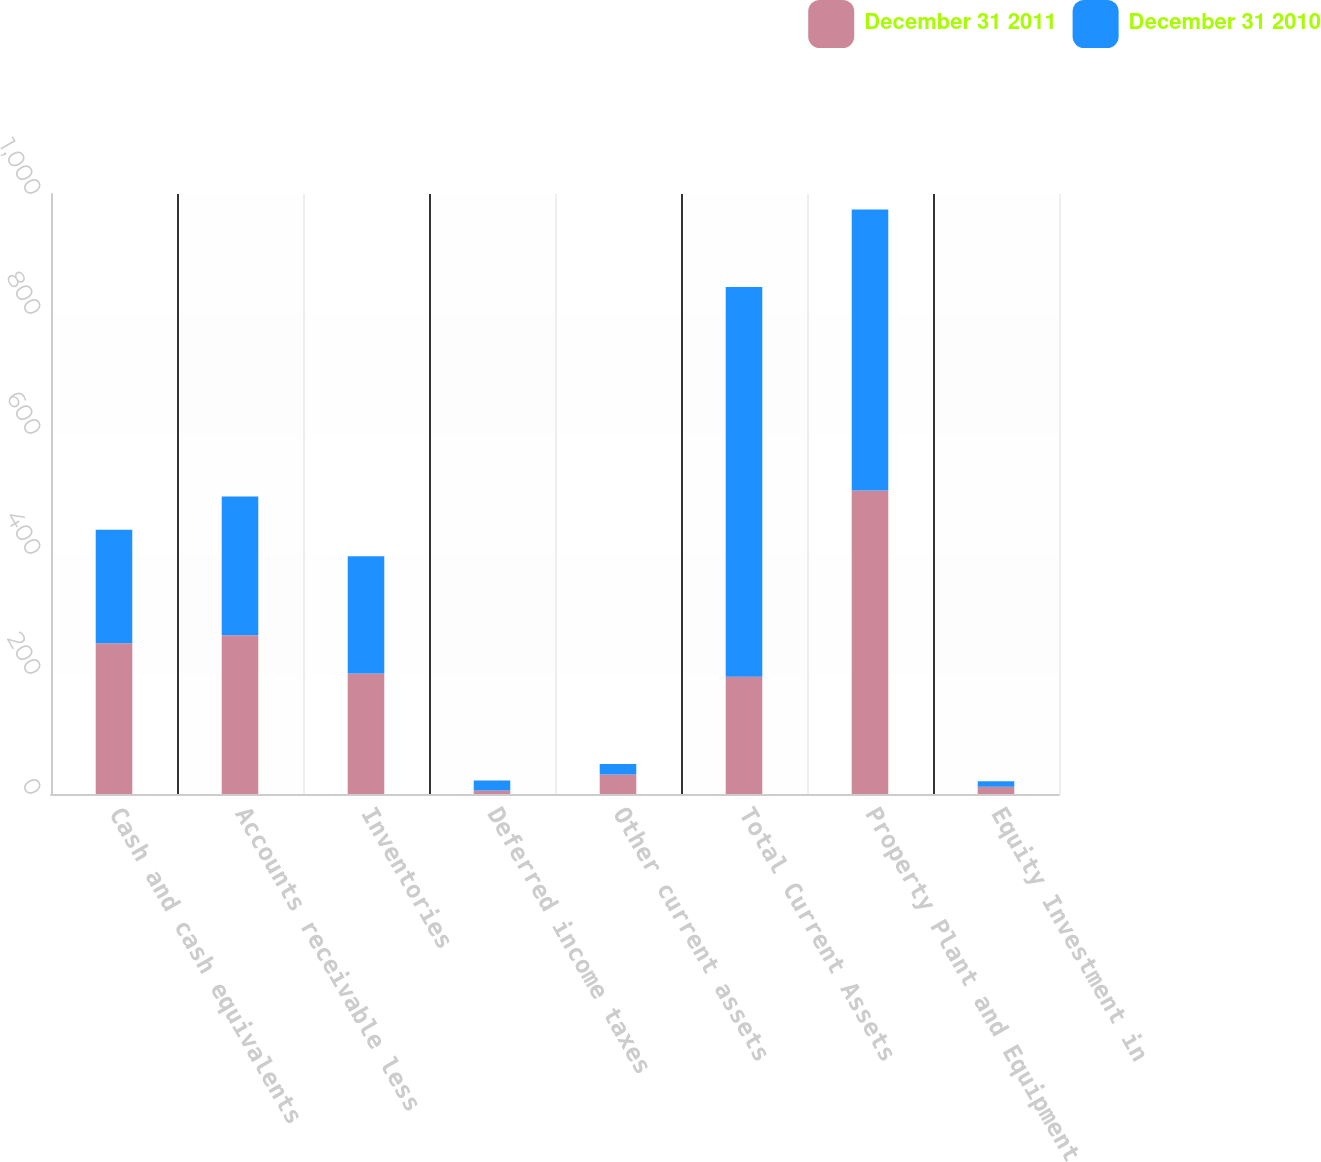Convert chart to OTSL. <chart><loc_0><loc_0><loc_500><loc_500><stacked_bar_chart><ecel><fcel>Cash and cash equivalents<fcel>Accounts receivable less<fcel>Inventories<fcel>Deferred income taxes<fcel>Other current assets<fcel>Total Current Assets<fcel>Property Plant and Equipment<fcel>Equity Investment in<nl><fcel>December 31 2011<fcel>251.4<fcel>264.6<fcel>200.7<fcel>6<fcel>32.5<fcel>195.4<fcel>506<fcel>12<nl><fcel>December 31 2010<fcel>189.2<fcel>231.1<fcel>195.4<fcel>16.3<fcel>17.5<fcel>649.5<fcel>468.3<fcel>9.2<nl></chart> 